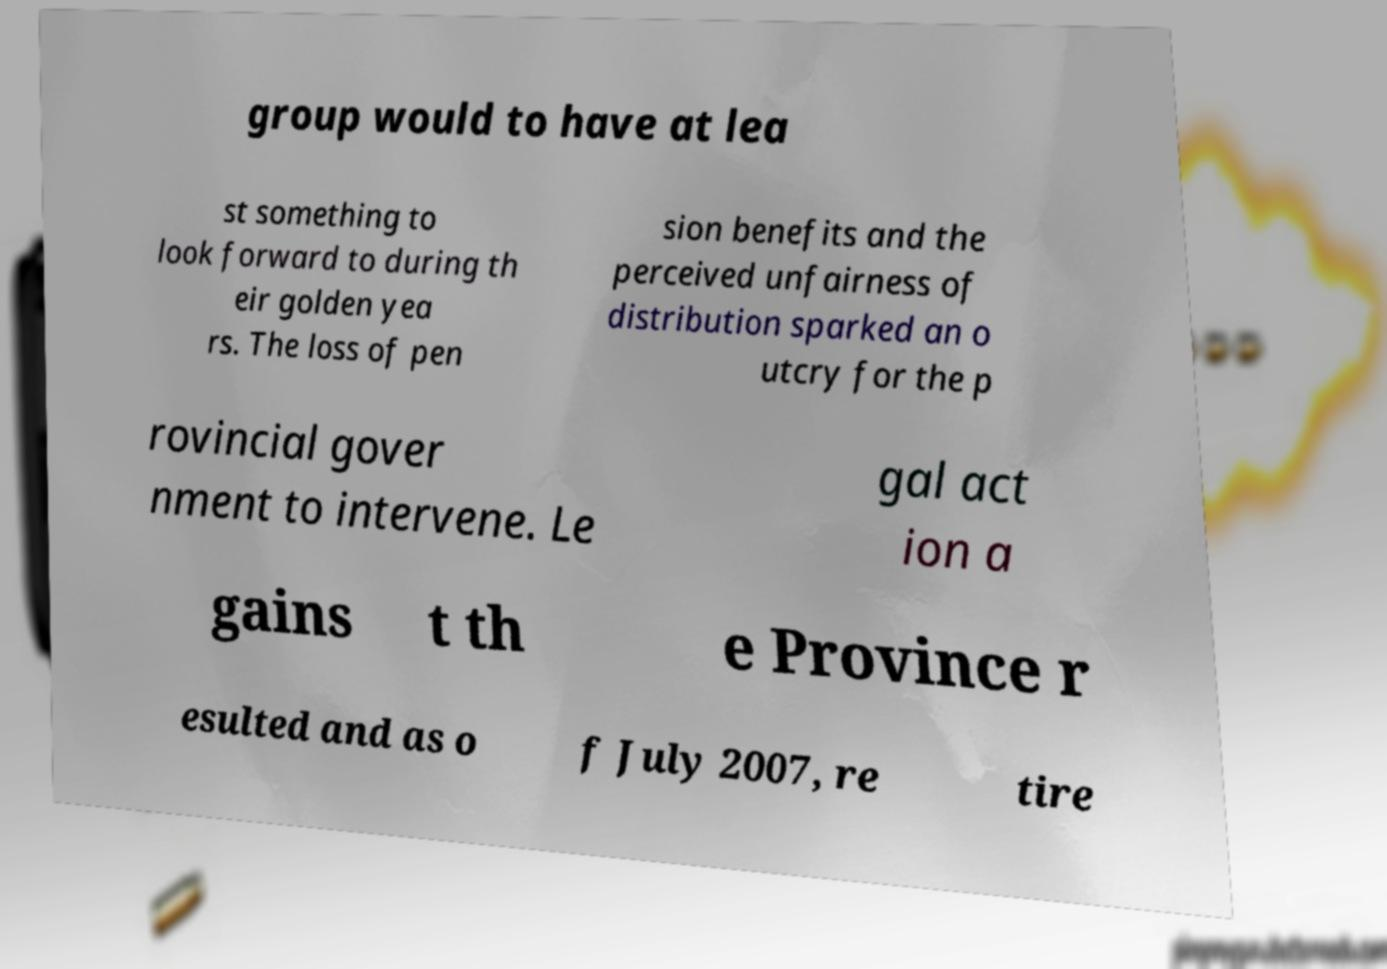I need the written content from this picture converted into text. Can you do that? group would to have at lea st something to look forward to during th eir golden yea rs. The loss of pen sion benefits and the perceived unfairness of distribution sparked an o utcry for the p rovincial gover nment to intervene. Le gal act ion a gains t th e Province r esulted and as o f July 2007, re tire 